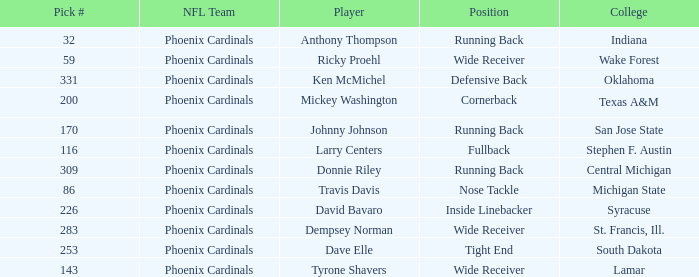Could you parse the entire table? {'header': ['Pick #', 'NFL Team', 'Player', 'Position', 'College'], 'rows': [['32', 'Phoenix Cardinals', 'Anthony Thompson', 'Running Back', 'Indiana'], ['59', 'Phoenix Cardinals', 'Ricky Proehl', 'Wide Receiver', 'Wake Forest'], ['331', 'Phoenix Cardinals', 'Ken McMichel', 'Defensive Back', 'Oklahoma'], ['200', 'Phoenix Cardinals', 'Mickey Washington', 'Cornerback', 'Texas A&M'], ['170', 'Phoenix Cardinals', 'Johnny Johnson', 'Running Back', 'San Jose State'], ['116', 'Phoenix Cardinals', 'Larry Centers', 'Fullback', 'Stephen F. Austin'], ['309', 'Phoenix Cardinals', 'Donnie Riley', 'Running Back', 'Central Michigan'], ['86', 'Phoenix Cardinals', 'Travis Davis', 'Nose Tackle', 'Michigan State'], ['226', 'Phoenix Cardinals', 'David Bavaro', 'Inside Linebacker', 'Syracuse'], ['283', 'Phoenix Cardinals', 'Dempsey Norman', 'Wide Receiver', 'St. Francis, Ill.'], ['253', 'Phoenix Cardinals', 'Dave Elle', 'Tight End', 'South Dakota'], ['143', 'Phoenix Cardinals', 'Tyrone Shavers', 'Wide Receiver', 'Lamar']]} Which NFL team has a pick# less than 200 for Travis Davis? Phoenix Cardinals. 